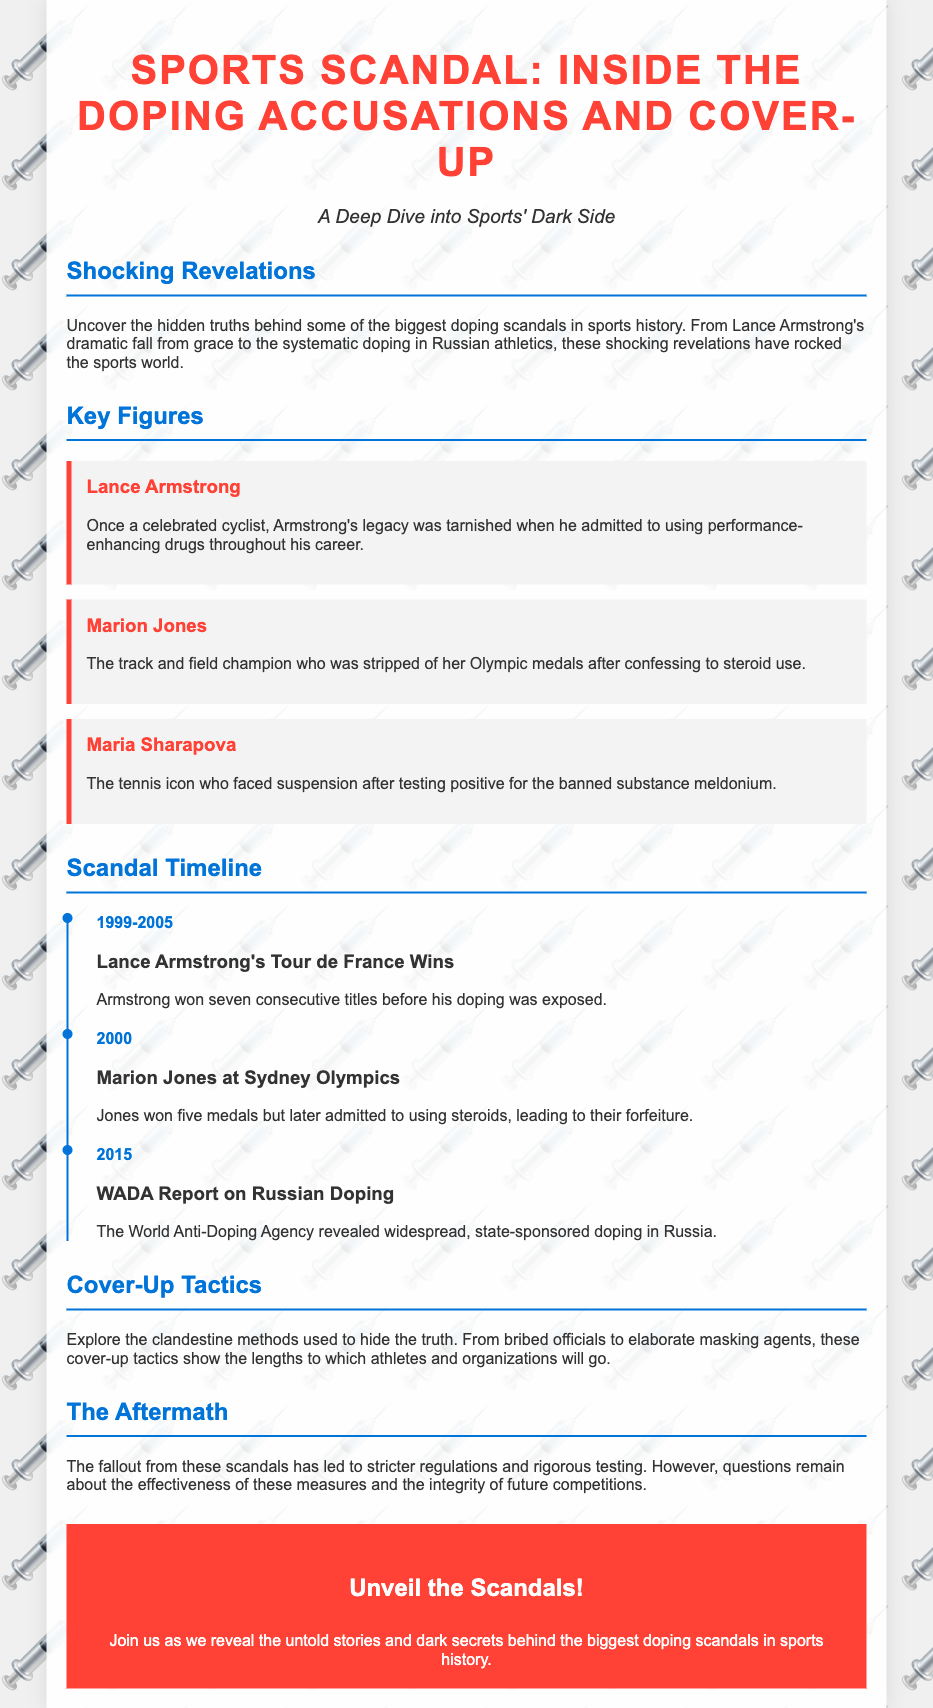What is the title of the poster? The title is prominently displayed at the top of the document and indicates the main topic being discussed.
Answer: Sports Scandal: Inside the Doping Accusations and Cover-Up Who admitted to using performance-enhancing drugs? This information can be found under the "Key Figures" section where notable athletes are mentioned.
Answer: Lance Armstrong In which year did Marion Jones admit to using steroids? The timeline event for Marion Jones mentions her admission and subsequent consequences related to the Sydney Olympics.
Answer: 2000 What organization revealed the state-sponsored doping in Russia? The document mentions an organization's report related to doping in Russia under the scandal timeline.
Answer: WADA How many consecutive Tour de France titles did Lance Armstrong win? The timeline highlights his accomplishments before the exposure of his doping.
Answer: Seven What was one of the tactics used to cover up doping practices? The document discusses various methods employed to conceal doping incidents in the cover-up section.
Answer: Bribed officials How many medals did Marion Jones win at the Sydney Olympics? The document states the number of medals she earned during this event before her confession.
Answer: Five What year did the WADA report on Russian doping come out? This information is indicated in the timeline provided under the "Scandal Timeline" section of the document.
Answer: 2015 What is the main focus of the document? The overarching theme encapsulated in the headline reveals the primary issue discussed throughout.
Answer: Doping accusations and cover-up 